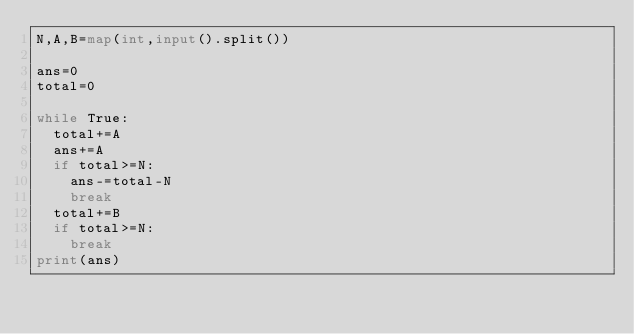Convert code to text. <code><loc_0><loc_0><loc_500><loc_500><_Python_>N,A,B=map(int,input().split())

ans=0
total=0

while True:
  total+=A
  ans+=A
  if total>=N:
    ans-=total-N
    break
  total+=B
  if total>=N:
    break
print(ans)</code> 